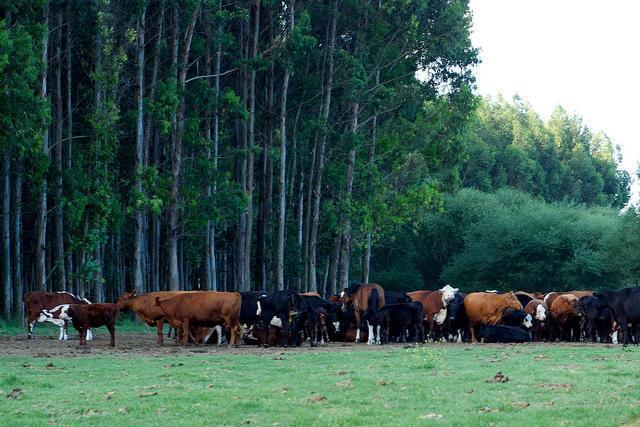What animal are these?
Pick the correct solution from the four options below to address the question.
Options: Cow, horse, donkey, goat. Cow. 